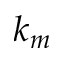Convert formula to latex. <formula><loc_0><loc_0><loc_500><loc_500>k _ { m }</formula> 